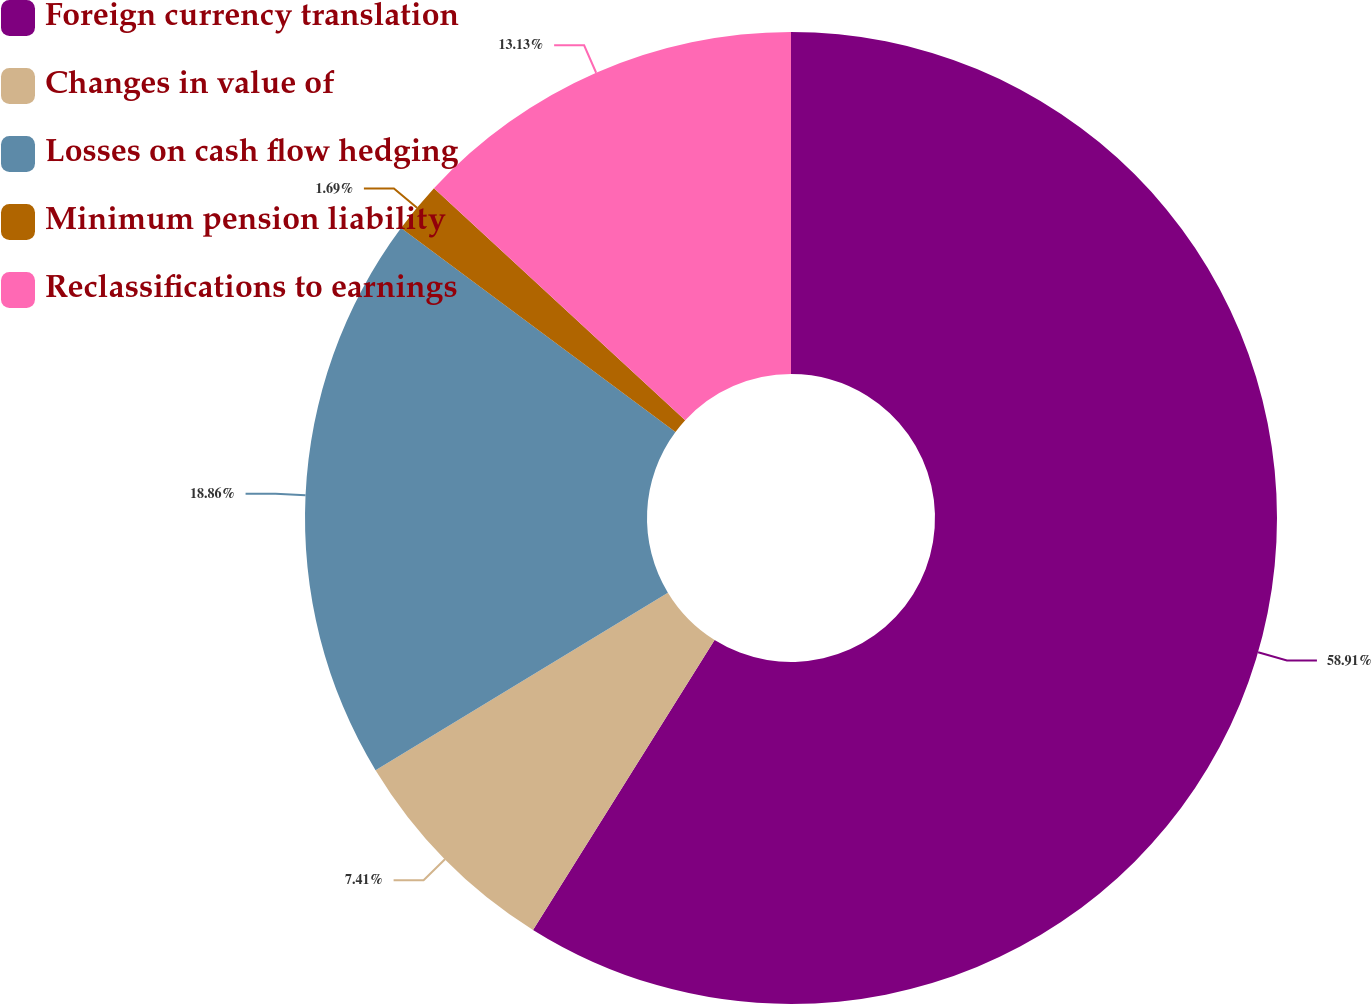Convert chart to OTSL. <chart><loc_0><loc_0><loc_500><loc_500><pie_chart><fcel>Foreign currency translation<fcel>Changes in value of<fcel>Losses on cash flow hedging<fcel>Minimum pension liability<fcel>Reclassifications to earnings<nl><fcel>58.9%<fcel>7.41%<fcel>18.86%<fcel>1.69%<fcel>13.13%<nl></chart> 